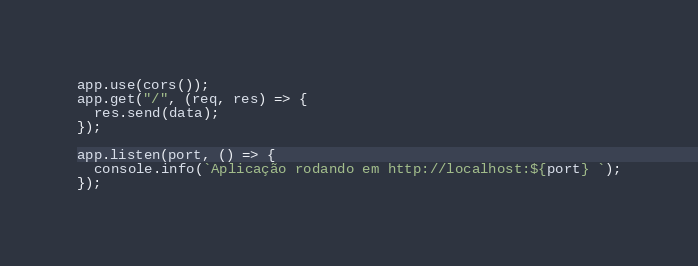<code> <loc_0><loc_0><loc_500><loc_500><_JavaScript_>
app.use(cors());
app.get("/", (req, res) => {
  res.send(data);
});

app.listen(port, () => {
  console.info(`Aplicação rodando em http://localhost:${port} `);
});
</code> 